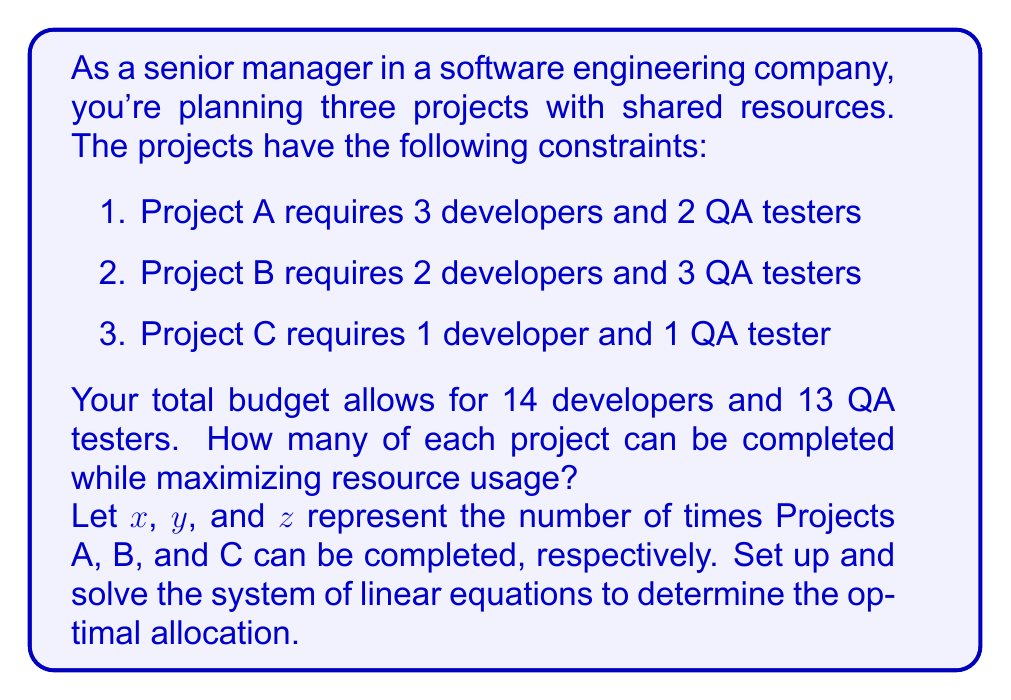What is the answer to this math problem? Let's approach this step-by-step:

1. Set up the system of linear equations:
   For developers: $3x + 2y + z = 14$
   For QA testers: $2x + 3y + z = 13$

2. We need to solve this system of equations. Let's use the substitution method.

3. From the first equation, express $z$ in terms of $x$ and $y$:
   $z = 14 - 3x - 2y$

4. Substitute this into the second equation:
   $2x + 3y + (14 - 3x - 2y) = 13$

5. Simplify:
   $2x + 3y + 14 - 3x - 2y = 13$
   $-x + y + 14 = 13$
   $-x + y = -1$

6. Now we have two equations:
   $3x + 2y = 14$
   $-x + y = -1$

7. Multiply the second equation by 3:
   $3x + 2y = 14$
   $-3x + 3y = -3$

8. Add these equations:
   $5y = 11$
   $y = \frac{11}{5} = 2.2$

9. Since we can't have fractional projects, we round down to $y = 2$

10. Substitute $y = 2$ into $-x + y = -1$:
    $-x + 2 = -1$
    $x = 3$

11. Now we can find $z$ using the original equation:
    $z = 14 - 3x - 2y = 14 - 3(3) - 2(2) = 14 - 9 - 4 = 1$

12. Check if this solution satisfies both original equations:
    Developers: $3(3) + 2(2) + 1(1) = 9 + 4 + 1 = 14$ ✓
    QA testers: $2(3) + 3(2) + 1(1) = 6 + 6 + 1 = 13$ ✓

Therefore, the optimal allocation is 3 of Project A, 2 of Project B, and 1 of Project C.
Answer: $(3, 2, 1)$ 